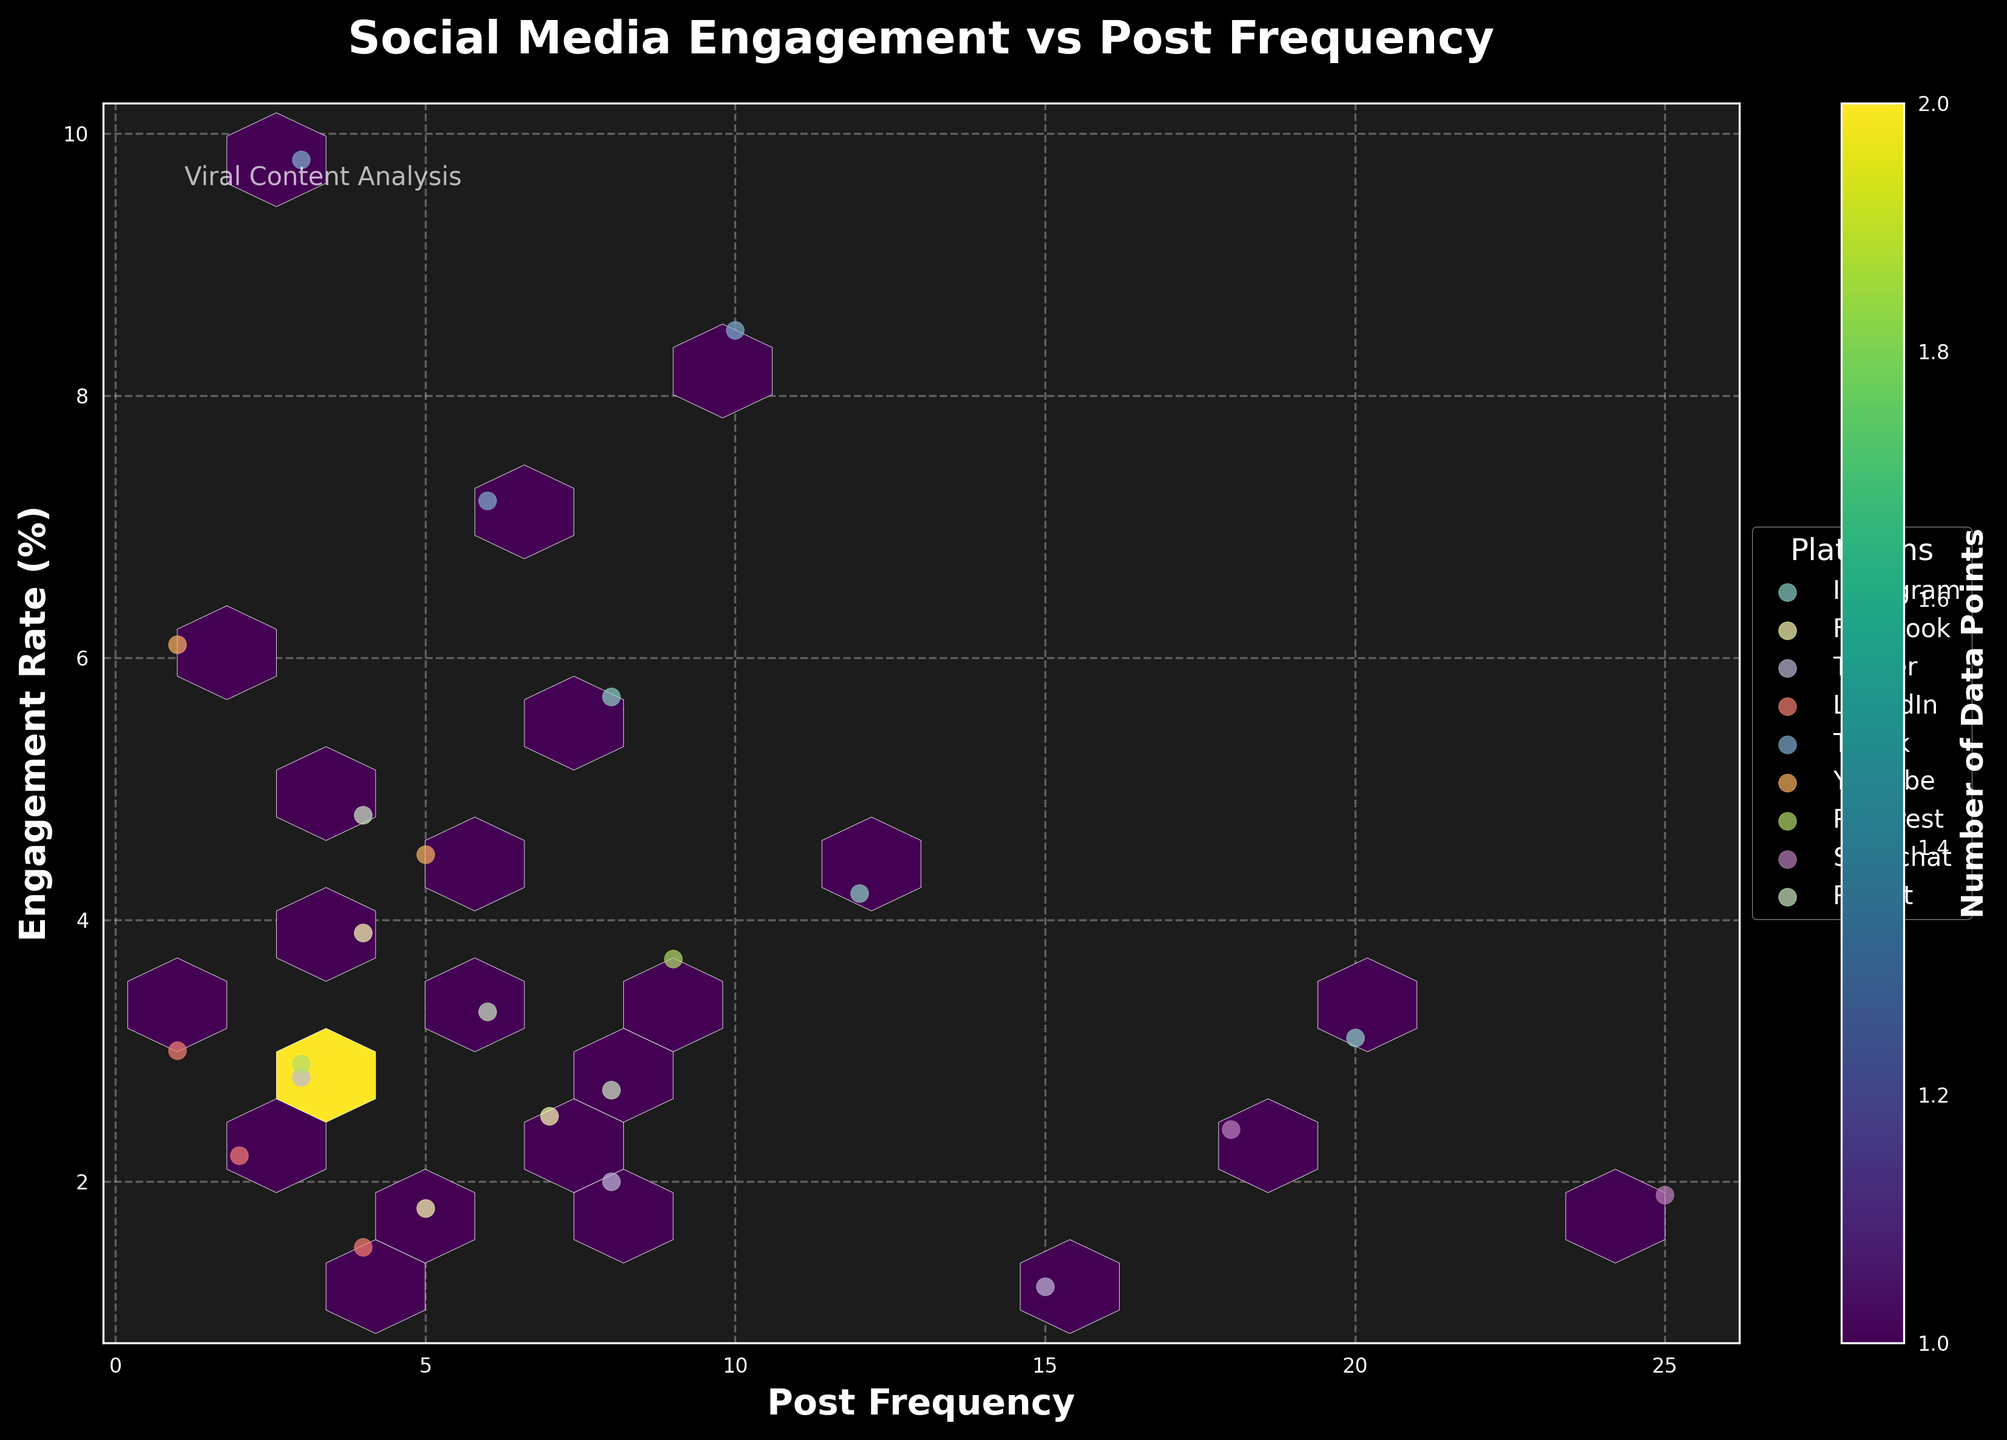What is the title of the plot? The title is usually found at the top of the plot and is intended to describe what the plot shows briefly. In this case, the title is written in bold at the top center of the figure.
Answer: Social Media Engagement vs Post Frequency What do the x-axis and y-axis represent? The labels on the x-axis and y-axis describe what the horizontal and vertical axes represent, respectively. Here, the x-axis is labeled 'Post Frequency' and the y-axis is labeled 'Engagement Rate (%)'.
Answer: Post Frequency, Engagement Rate (%) Which platform shows the highest engagement rate? By observing the scatter points on the plot, particularly those at the upper range of the y-axis, we identify the platform with the highest engagement rate. TikTok's data points are at the highest position on the y-axis, indicating the highest engagement rate.
Answer: TikTok How many platforms are included in the plot? Platforms are represented by different scatter point markers and denoted in the legend box on the right side of the plot. Counting the unique entries in the legend gives the number of platforms. The platforms shown are Instagram, Facebook, Twitter, LinkedIn, TikTok, YouTube, Pinterest, Snapchat, and Reddit.
Answer: 9 Which platform has data points with the lowest combination of post frequency and engagement rate? By examining the lower-left corner of the plot where both axes’ values are minimum, we see that LinkedIn has data points situated at these minimum values, indicating the lowest combination.
Answer: LinkedIn What does the color in the hexbin represent? The color bar to the right of the hexbin plot and the label ‘Number of Data Points’ explain the meaning of the colors. The shades of color within the hexbin denote the number of data points present in that area.
Answer: Number of Data Points What platform does the scatter point at the highest post frequency belong to? By looking at the far end of the x-axis (post frequency), we observe that Snapchat has a point at the highest post frequency value, according to the scatter color.
Answer: Snapchat Compare the engagement rates of Instagram Video and Facebook Video based on their positions in the plot. To compare these two, we find their scatter points in relation to the y-axis (engagement rate). Instagram Video's point is higher on the y-axis compared to Facebook Video, indicating that Instagram Video has a higher engagement rate.
Answer: Instagram Video is higher Which content type on TikTok has the highest engagement rate, and what is its approximate value? By locating TikTok's highest points on the y-axis (engagement rate) and identifying the content type, TikTok Challenge is at the highest engagement rate point. The y-axis shows this rate is around 9.8.
Answer: Challenge, 9.8 What does the label within the hexbin plot 'Viral Content Analysis' signify? The small text at the top-left inside the plot typically indicates an additional note or context related to the plot. Here, it suggests that the plot is an analysis aimed at understanding viral content.
Answer: It's a contextual note indicating the focus on viral content analysis 